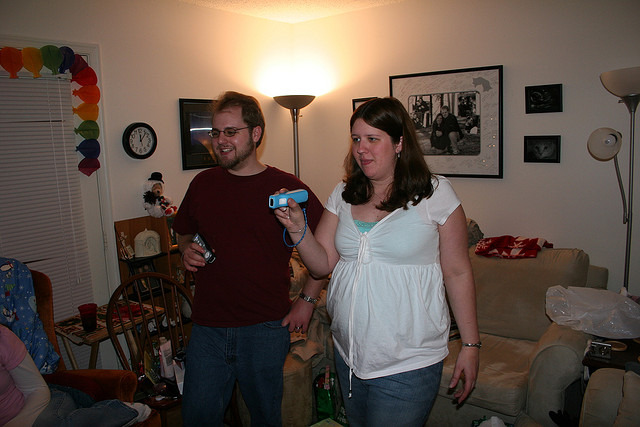<image>What color is the man's badge? There is no badge on the man. However, it can be seen black, red or gold. What character is depicted on the poster above the woman? It is unknown what character is depicted on the poster above the woman. It could be a family, a couple, or friends. What color is the girl's hat? The girl is not wearing a hat. What is the lightning? I am not sure what the lightning is. It might be a floor lamp or a lamp. What color is the man's badge? I am not sure what color is the man's badge. It is either black, red, gold or there is no badge. What color is the girl's hat? The girl is not wearing a hat. What is the lightning? I don't know what the lightning is exactly. It can be a floor lamp or a regular lamp. What character is depicted on the poster above the woman? I don't know which character is depicted on the poster above the woman. There could be various possibilities such as 'family', 'photo', 'cat', 'author', 'couple', 'friends', or 'man and woman'. 